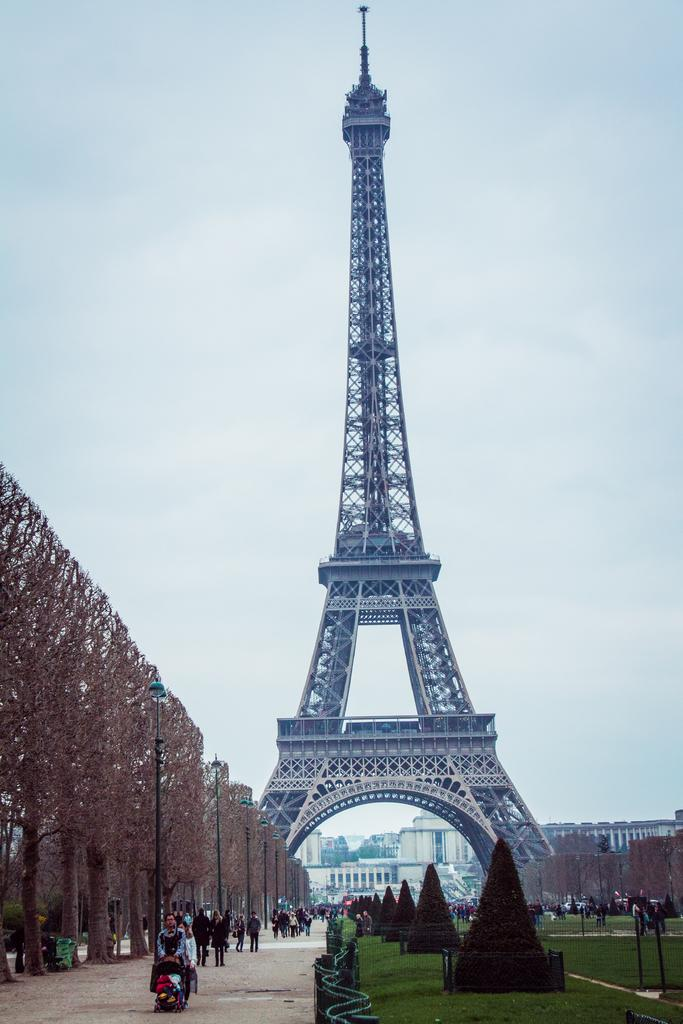What type of vegetation can be seen in the image? There are trees, plants, and grass visible in the image. What structures are present in the image? There are poles and buildings visible in the image. Are there any people in the image? Yes, there are persons in the image. What is visible in the background of the image? There are buildings, the Eiffel Tower, objects, and clouds in the sky in the background of the image. What type of patch is being used by the persons in the image? There is no patch visible in the image; the persons are not using any patches. What type of paper can be seen in the image? There is no paper present in the image. 